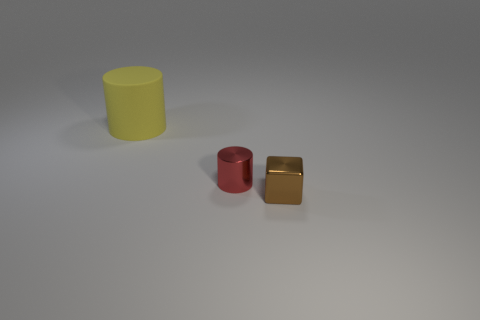Does the red shiny thing have the same shape as the yellow rubber thing?
Your response must be concise. Yes. The cylinder that is on the left side of the cylinder that is to the right of the cylinder that is behind the red metal thing is what color?
Your answer should be very brief. Yellow. What number of other tiny objects have the same shape as the matte thing?
Provide a short and direct response. 1. There is a object that is in front of the cylinder that is right of the rubber object; how big is it?
Provide a short and direct response. Small. Do the shiny block and the red metal object have the same size?
Your answer should be compact. Yes. Are there any red metallic objects that are on the left side of the small thing to the right of the cylinder on the right side of the large cylinder?
Your answer should be compact. Yes. The cube is what size?
Your response must be concise. Small. How many brown metal cubes have the same size as the metallic cylinder?
Ensure brevity in your answer.  1. There is another red thing that is the same shape as the large rubber object; what is its material?
Keep it short and to the point. Metal. What is the shape of the object that is both in front of the large matte object and behind the brown thing?
Offer a terse response. Cylinder. 